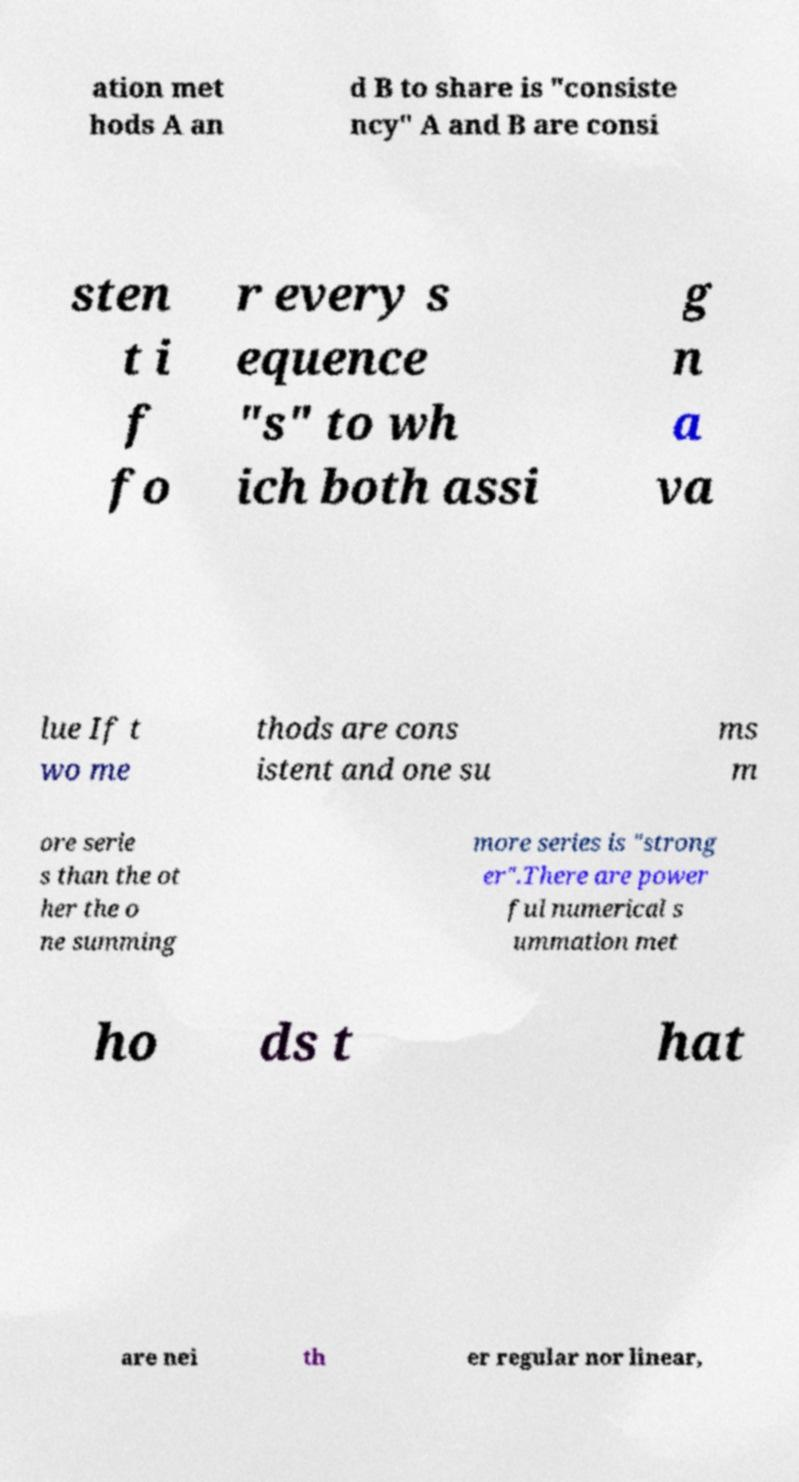Please identify and transcribe the text found in this image. ation met hods A an d B to share is "consiste ncy" A and B are consi sten t i f fo r every s equence "s" to wh ich both assi g n a va lue If t wo me thods are cons istent and one su ms m ore serie s than the ot her the o ne summing more series is "strong er".There are power ful numerical s ummation met ho ds t hat are nei th er regular nor linear, 